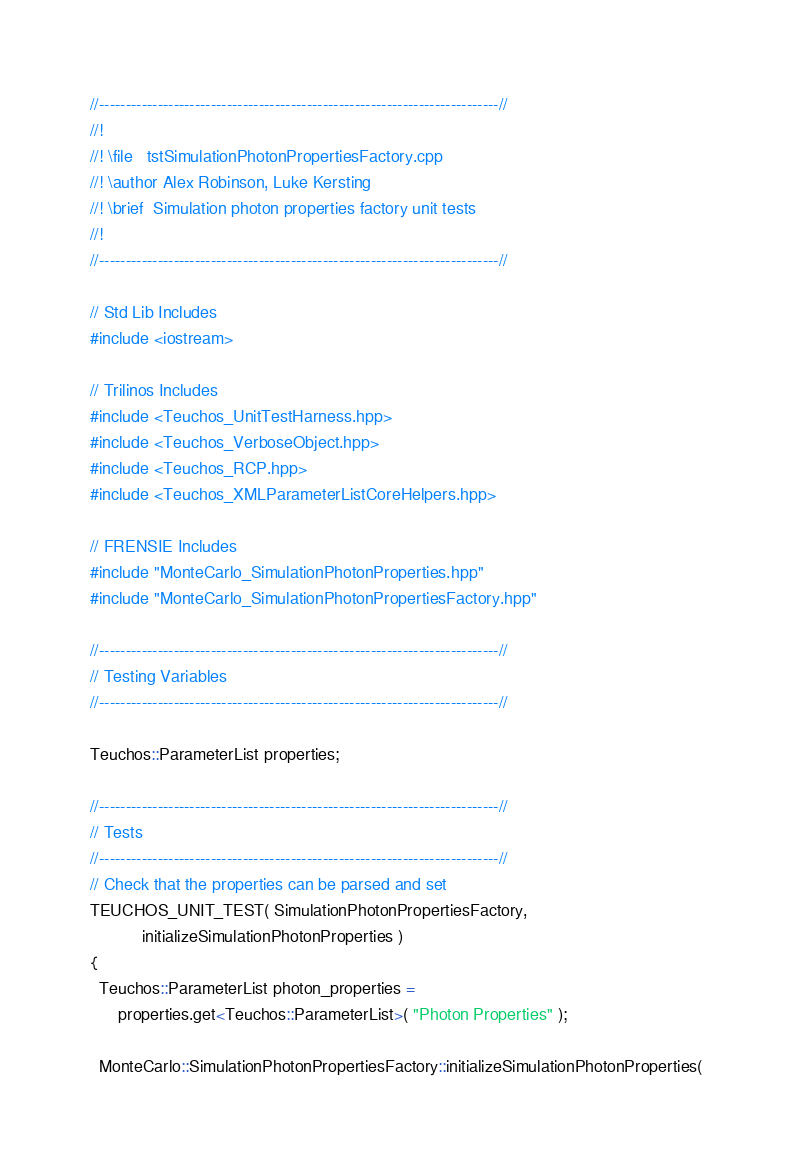<code> <loc_0><loc_0><loc_500><loc_500><_C++_>//---------------------------------------------------------------------------//
//!
//! \file   tstSimulationPhotonPropertiesFactory.cpp
//! \author Alex Robinson, Luke Kersting
//! \brief  Simulation photon properties factory unit tests
//!
//---------------------------------------------------------------------------//

// Std Lib Includes
#include <iostream>

// Trilinos Includes
#include <Teuchos_UnitTestHarness.hpp>
#include <Teuchos_VerboseObject.hpp>
#include <Teuchos_RCP.hpp>
#include <Teuchos_XMLParameterListCoreHelpers.hpp>

// FRENSIE Includes
#include "MonteCarlo_SimulationPhotonProperties.hpp"
#include "MonteCarlo_SimulationPhotonPropertiesFactory.hpp"

//---------------------------------------------------------------------------//
// Testing Variables
//---------------------------------------------------------------------------//

Teuchos::ParameterList properties;

//---------------------------------------------------------------------------//
// Tests
//---------------------------------------------------------------------------//
// Check that the properties can be parsed and set
TEUCHOS_UNIT_TEST( SimulationPhotonPropertiesFactory,
		   initializeSimulationPhotonProperties )
{
  Teuchos::ParameterList photon_properties = 
      properties.get<Teuchos::ParameterList>( "Photon Properties" );

  MonteCarlo::SimulationPhotonPropertiesFactory::initializeSimulationPhotonProperties( </code> 